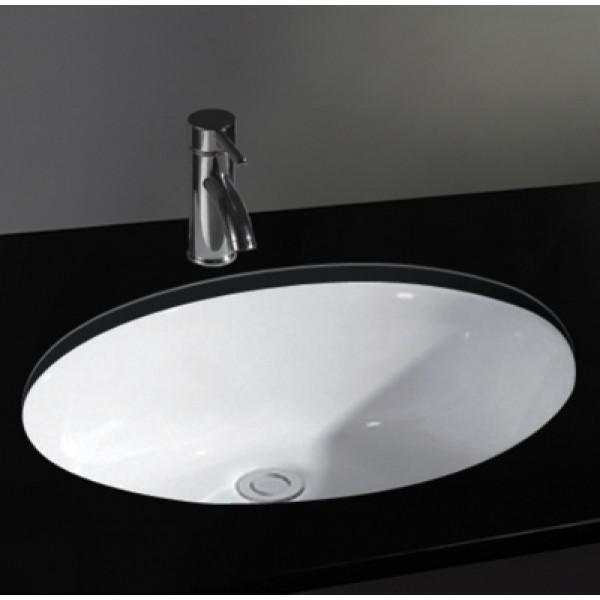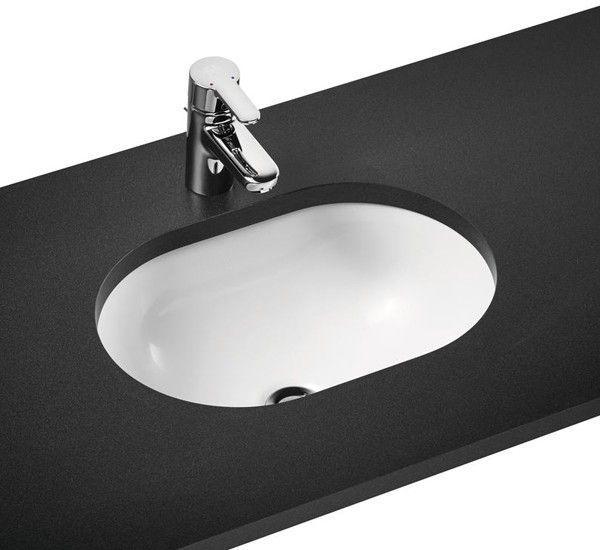The first image is the image on the left, the second image is the image on the right. Evaluate the accuracy of this statement regarding the images: "There are two oval shaped sinks installed in countertops.". Is it true? Answer yes or no. Yes. The first image is the image on the left, the second image is the image on the right. Examine the images to the left and right. Is the description "An image shows a sink with a semi-circle interior and chrome fixture mounted to the basin's top." accurate? Answer yes or no. No. 